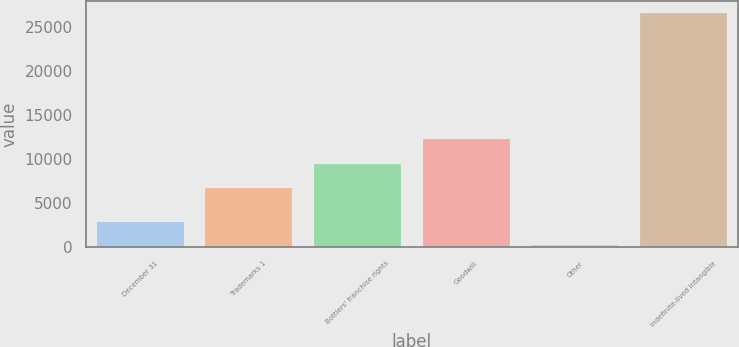<chart> <loc_0><loc_0><loc_500><loc_500><bar_chart><fcel>December 31<fcel>Trademarks 1<fcel>Bottlers' franchise rights<fcel>Goodwill<fcel>Other<fcel>Indefinite-lived intangible<nl><fcel>2818.1<fcel>6744<fcel>9391.1<fcel>12312<fcel>171<fcel>26642<nl></chart> 